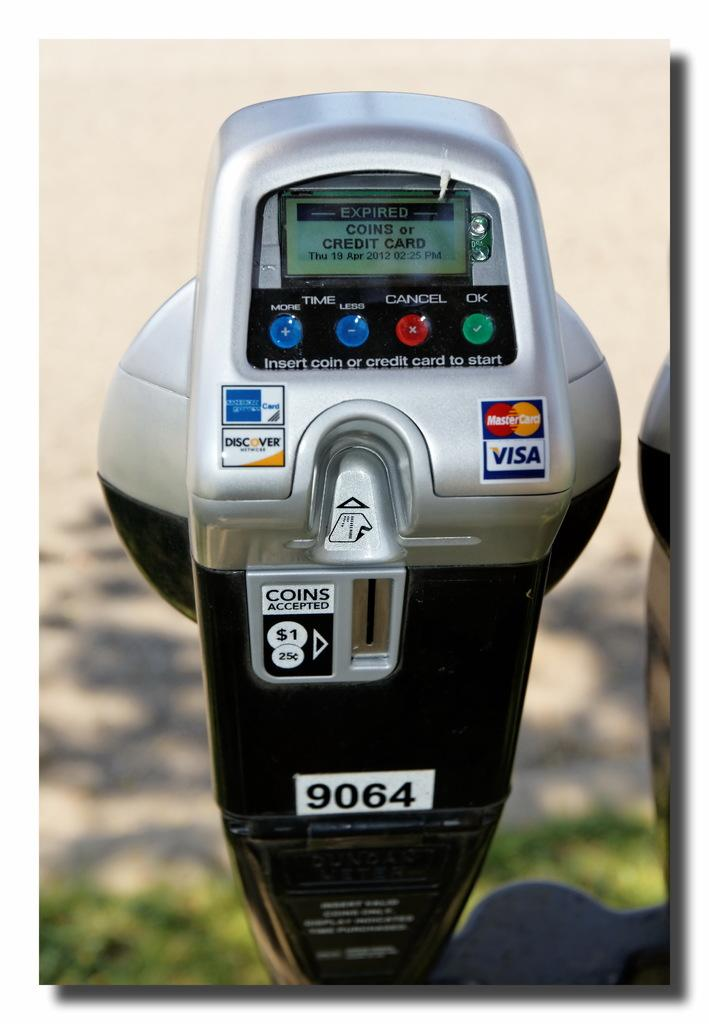Provide a one-sentence caption for the provided image. A parking meter that accepts coils, American Express, Discover, Mastercard, or Visa. 